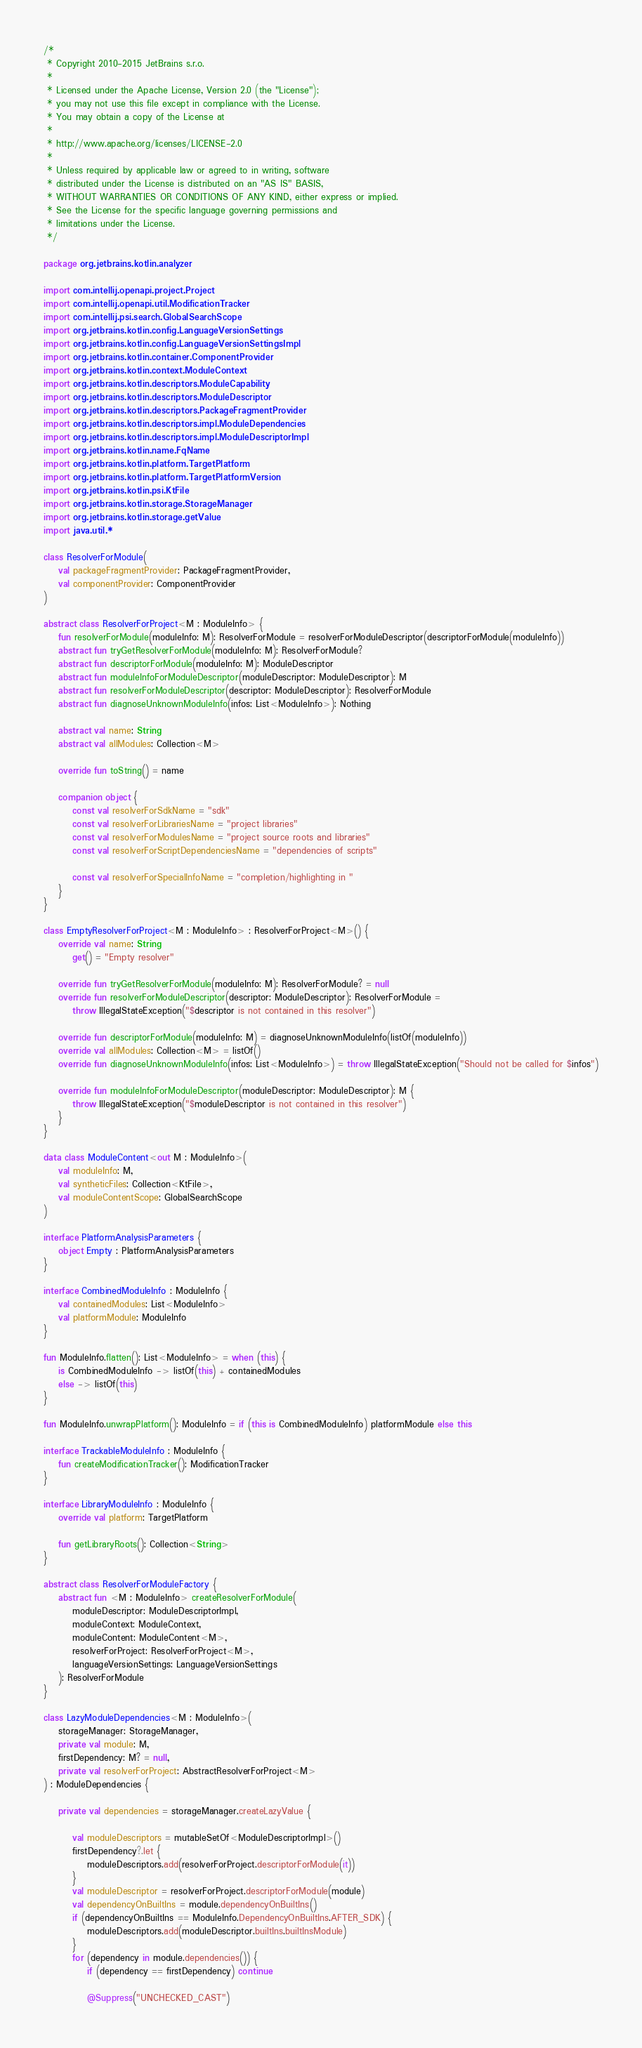Convert code to text. <code><loc_0><loc_0><loc_500><loc_500><_Kotlin_>/*
 * Copyright 2010-2015 JetBrains s.r.o.
 *
 * Licensed under the Apache License, Version 2.0 (the "License");
 * you may not use this file except in compliance with the License.
 * You may obtain a copy of the License at
 *
 * http://www.apache.org/licenses/LICENSE-2.0
 *
 * Unless required by applicable law or agreed to in writing, software
 * distributed under the License is distributed on an "AS IS" BASIS,
 * WITHOUT WARRANTIES OR CONDITIONS OF ANY KIND, either express or implied.
 * See the License for the specific language governing permissions and
 * limitations under the License.
 */

package org.jetbrains.kotlin.analyzer

import com.intellij.openapi.project.Project
import com.intellij.openapi.util.ModificationTracker
import com.intellij.psi.search.GlobalSearchScope
import org.jetbrains.kotlin.config.LanguageVersionSettings
import org.jetbrains.kotlin.config.LanguageVersionSettingsImpl
import org.jetbrains.kotlin.container.ComponentProvider
import org.jetbrains.kotlin.context.ModuleContext
import org.jetbrains.kotlin.descriptors.ModuleCapability
import org.jetbrains.kotlin.descriptors.ModuleDescriptor
import org.jetbrains.kotlin.descriptors.PackageFragmentProvider
import org.jetbrains.kotlin.descriptors.impl.ModuleDependencies
import org.jetbrains.kotlin.descriptors.impl.ModuleDescriptorImpl
import org.jetbrains.kotlin.name.FqName
import org.jetbrains.kotlin.platform.TargetPlatform
import org.jetbrains.kotlin.platform.TargetPlatformVersion
import org.jetbrains.kotlin.psi.KtFile
import org.jetbrains.kotlin.storage.StorageManager
import org.jetbrains.kotlin.storage.getValue
import java.util.*

class ResolverForModule(
    val packageFragmentProvider: PackageFragmentProvider,
    val componentProvider: ComponentProvider
)

abstract class ResolverForProject<M : ModuleInfo> {
    fun resolverForModule(moduleInfo: M): ResolverForModule = resolverForModuleDescriptor(descriptorForModule(moduleInfo))
    abstract fun tryGetResolverForModule(moduleInfo: M): ResolverForModule?
    abstract fun descriptorForModule(moduleInfo: M): ModuleDescriptor
    abstract fun moduleInfoForModuleDescriptor(moduleDescriptor: ModuleDescriptor): M
    abstract fun resolverForModuleDescriptor(descriptor: ModuleDescriptor): ResolverForModule
    abstract fun diagnoseUnknownModuleInfo(infos: List<ModuleInfo>): Nothing

    abstract val name: String
    abstract val allModules: Collection<M>

    override fun toString() = name

    companion object {
        const val resolverForSdkName = "sdk"
        const val resolverForLibrariesName = "project libraries"
        const val resolverForModulesName = "project source roots and libraries"
        const val resolverForScriptDependenciesName = "dependencies of scripts"

        const val resolverForSpecialInfoName = "completion/highlighting in "
    }
}

class EmptyResolverForProject<M : ModuleInfo> : ResolverForProject<M>() {
    override val name: String
        get() = "Empty resolver"

    override fun tryGetResolverForModule(moduleInfo: M): ResolverForModule? = null
    override fun resolverForModuleDescriptor(descriptor: ModuleDescriptor): ResolverForModule =
        throw IllegalStateException("$descriptor is not contained in this resolver")

    override fun descriptorForModule(moduleInfo: M) = diagnoseUnknownModuleInfo(listOf(moduleInfo))
    override val allModules: Collection<M> = listOf()
    override fun diagnoseUnknownModuleInfo(infos: List<ModuleInfo>) = throw IllegalStateException("Should not be called for $infos")

    override fun moduleInfoForModuleDescriptor(moduleDescriptor: ModuleDescriptor): M {
        throw IllegalStateException("$moduleDescriptor is not contained in this resolver")
    }
}

data class ModuleContent<out M : ModuleInfo>(
    val moduleInfo: M,
    val syntheticFiles: Collection<KtFile>,
    val moduleContentScope: GlobalSearchScope
)

interface PlatformAnalysisParameters {
    object Empty : PlatformAnalysisParameters
}

interface CombinedModuleInfo : ModuleInfo {
    val containedModules: List<ModuleInfo>
    val platformModule: ModuleInfo
}

fun ModuleInfo.flatten(): List<ModuleInfo> = when (this) {
    is CombinedModuleInfo -> listOf(this) + containedModules
    else -> listOf(this)
}

fun ModuleInfo.unwrapPlatform(): ModuleInfo = if (this is CombinedModuleInfo) platformModule else this

interface TrackableModuleInfo : ModuleInfo {
    fun createModificationTracker(): ModificationTracker
}

interface LibraryModuleInfo : ModuleInfo {
    override val platform: TargetPlatform

    fun getLibraryRoots(): Collection<String>
}

abstract class ResolverForModuleFactory {
    abstract fun <M : ModuleInfo> createResolverForModule(
        moduleDescriptor: ModuleDescriptorImpl,
        moduleContext: ModuleContext,
        moduleContent: ModuleContent<M>,
        resolverForProject: ResolverForProject<M>,
        languageVersionSettings: LanguageVersionSettings
    ): ResolverForModule
}

class LazyModuleDependencies<M : ModuleInfo>(
    storageManager: StorageManager,
    private val module: M,
    firstDependency: M? = null,
    private val resolverForProject: AbstractResolverForProject<M>
) : ModuleDependencies {

    private val dependencies = storageManager.createLazyValue {

        val moduleDescriptors = mutableSetOf<ModuleDescriptorImpl>()
        firstDependency?.let {
            moduleDescriptors.add(resolverForProject.descriptorForModule(it))
        }
        val moduleDescriptor = resolverForProject.descriptorForModule(module)
        val dependencyOnBuiltIns = module.dependencyOnBuiltIns()
        if (dependencyOnBuiltIns == ModuleInfo.DependencyOnBuiltIns.AFTER_SDK) {
            moduleDescriptors.add(moduleDescriptor.builtIns.builtInsModule)
        }
        for (dependency in module.dependencies()) {
            if (dependency == firstDependency) continue

            @Suppress("UNCHECKED_CAST")</code> 